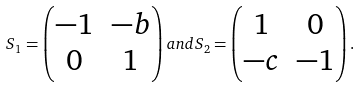Convert formula to latex. <formula><loc_0><loc_0><loc_500><loc_500>S _ { 1 } = \begin{pmatrix} - 1 & - b \\ 0 & 1 \end{pmatrix} a n d S _ { 2 } = \begin{pmatrix} 1 & 0 \\ - c & - 1 \end{pmatrix} .</formula> 